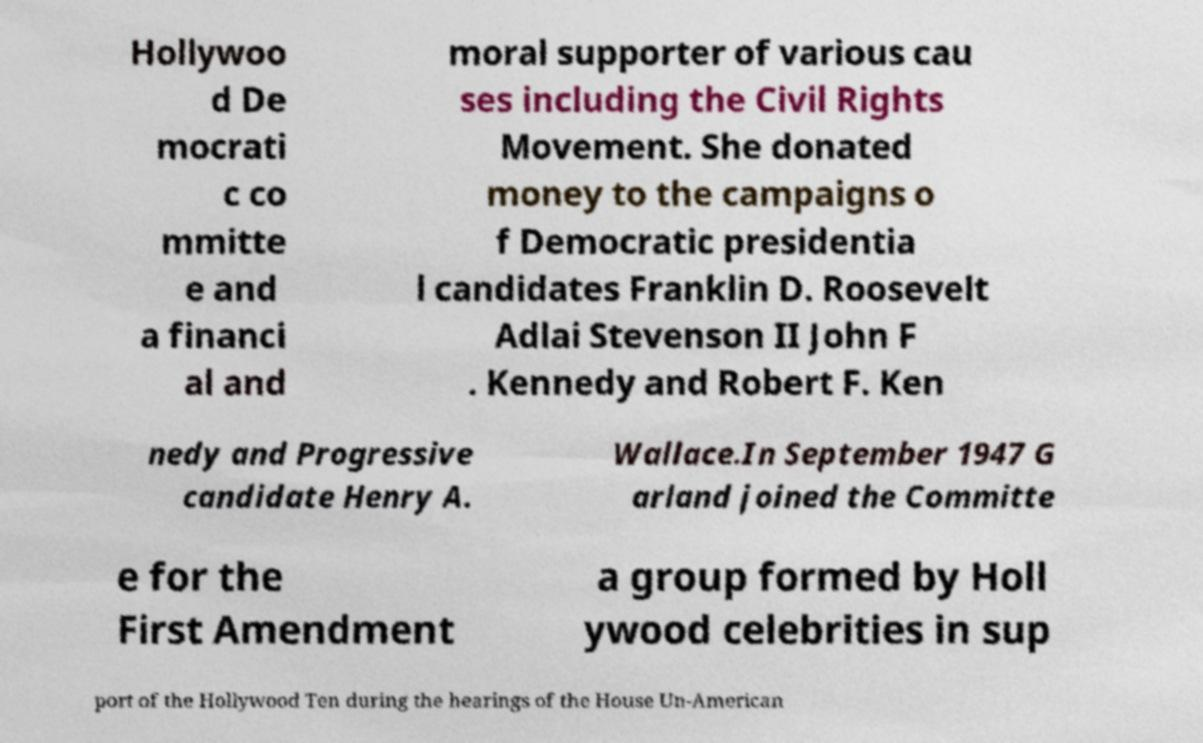For documentation purposes, I need the text within this image transcribed. Could you provide that? Hollywoo d De mocrati c co mmitte e and a financi al and moral supporter of various cau ses including the Civil Rights Movement. She donated money to the campaigns o f Democratic presidentia l candidates Franklin D. Roosevelt Adlai Stevenson II John F . Kennedy and Robert F. Ken nedy and Progressive candidate Henry A. Wallace.In September 1947 G arland joined the Committe e for the First Amendment a group formed by Holl ywood celebrities in sup port of the Hollywood Ten during the hearings of the House Un-American 